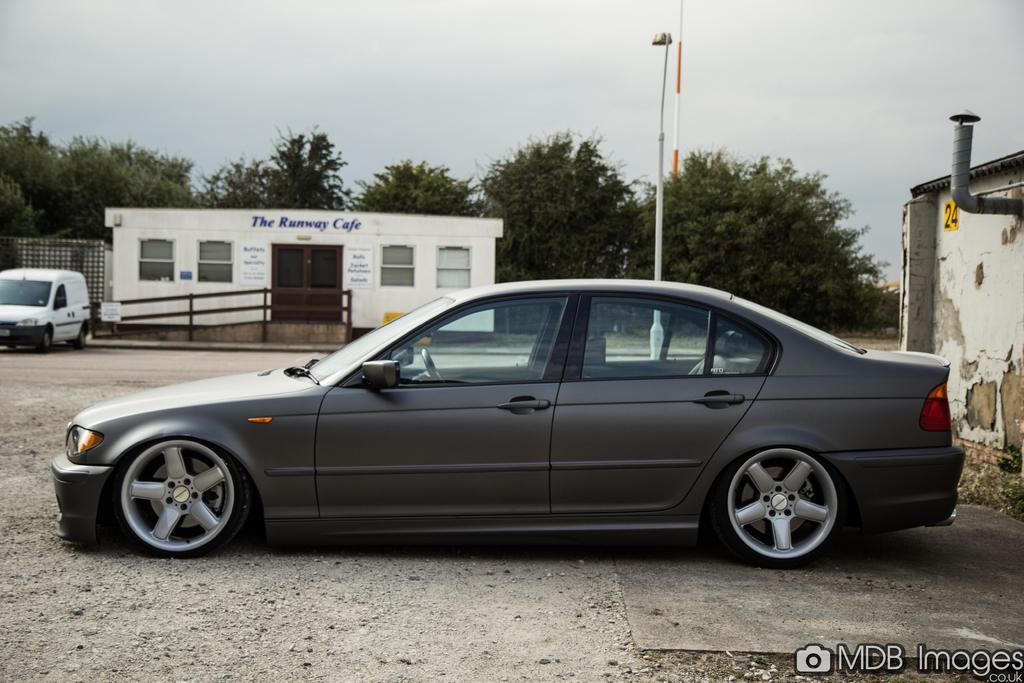How would you summarize this image in a sentence or two? Here we can see poles, cars, houses, posters, and trees. In the background there is sky. 